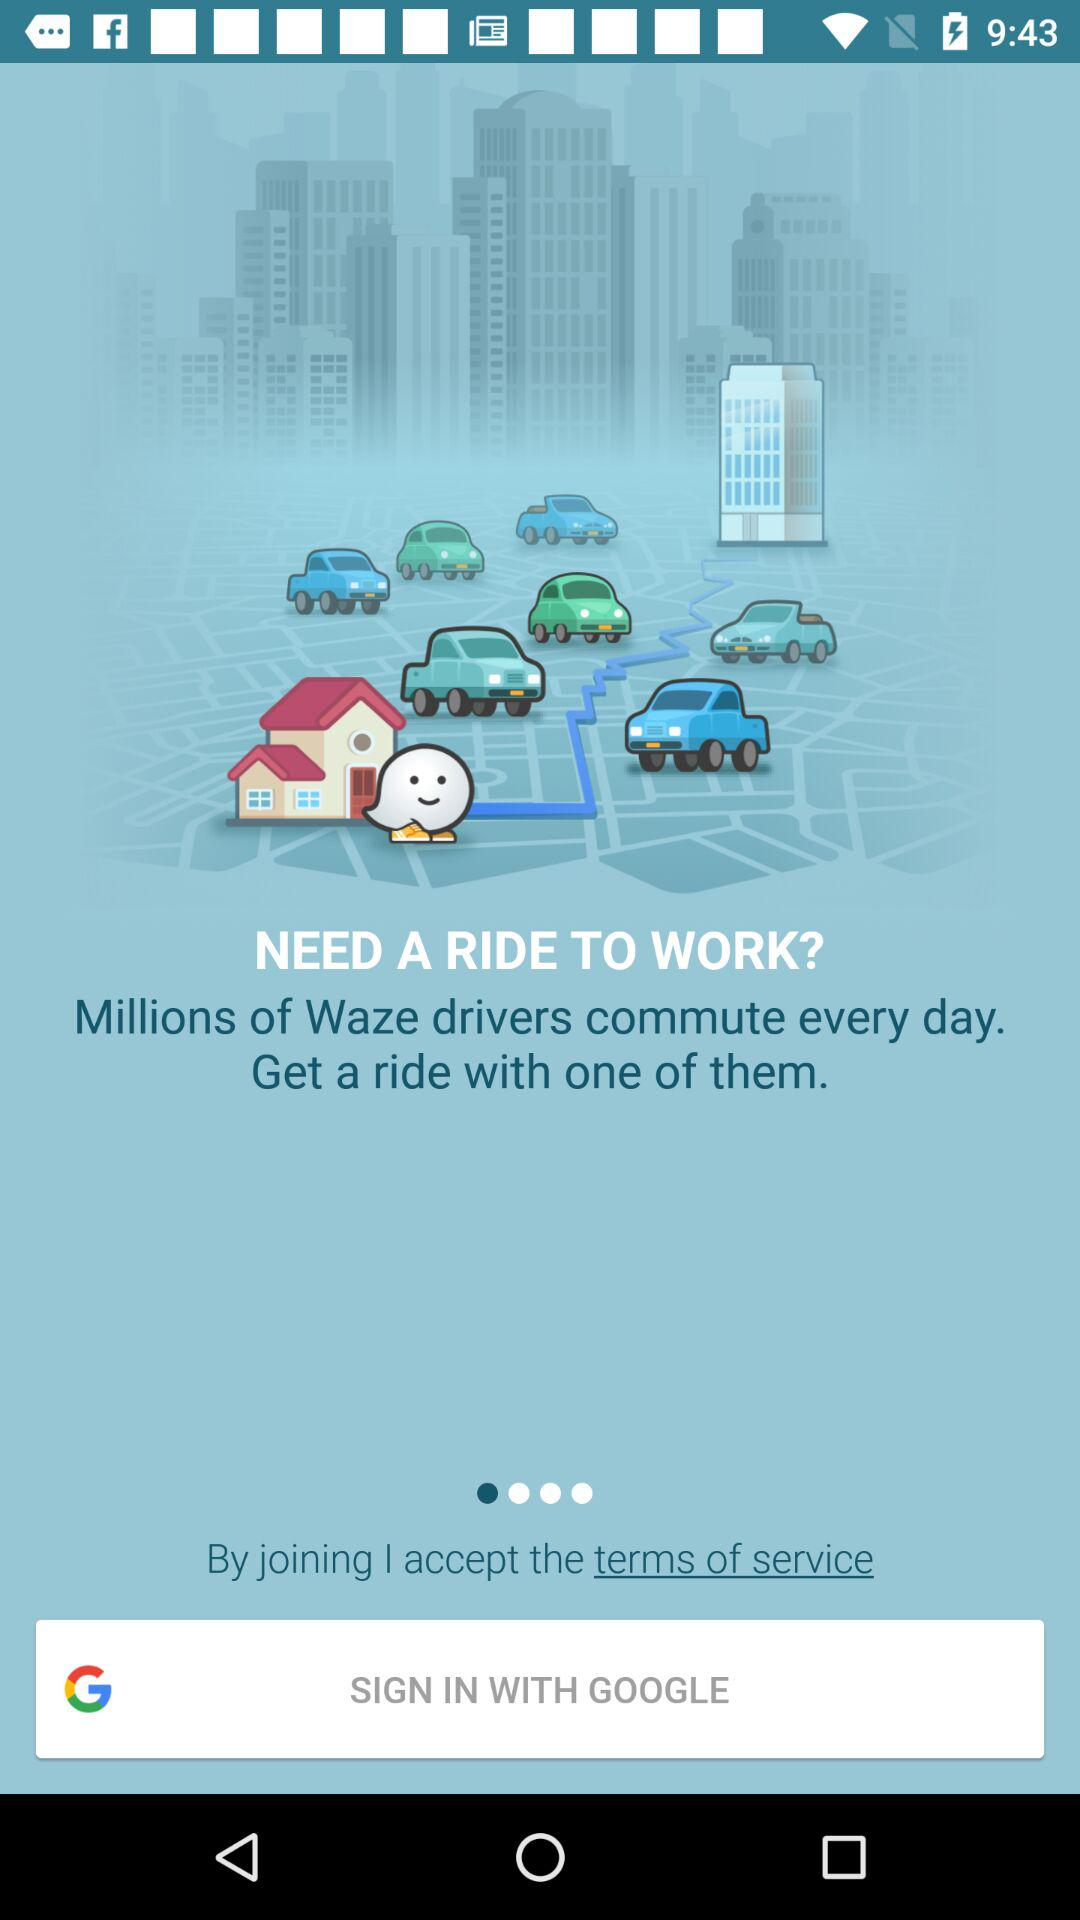Through what application can we sign in? You can sign in through "GOOGLE". 